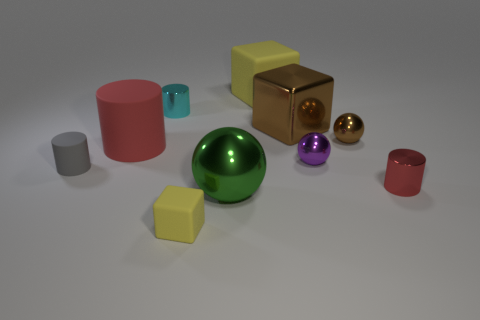Subtract all gray cylinders. How many yellow blocks are left? 2 Subtract all tiny gray cylinders. How many cylinders are left? 3 Subtract all gray cylinders. How many cylinders are left? 3 Subtract 1 cubes. How many cubes are left? 2 Subtract all blue cylinders. Subtract all blue blocks. How many cylinders are left? 4 Subtract all cylinders. How many objects are left? 6 Subtract all tiny gray things. Subtract all big blue rubber things. How many objects are left? 9 Add 1 small purple balls. How many small purple balls are left? 2 Add 6 gray metal cubes. How many gray metal cubes exist? 6 Subtract 0 blue cylinders. How many objects are left? 10 